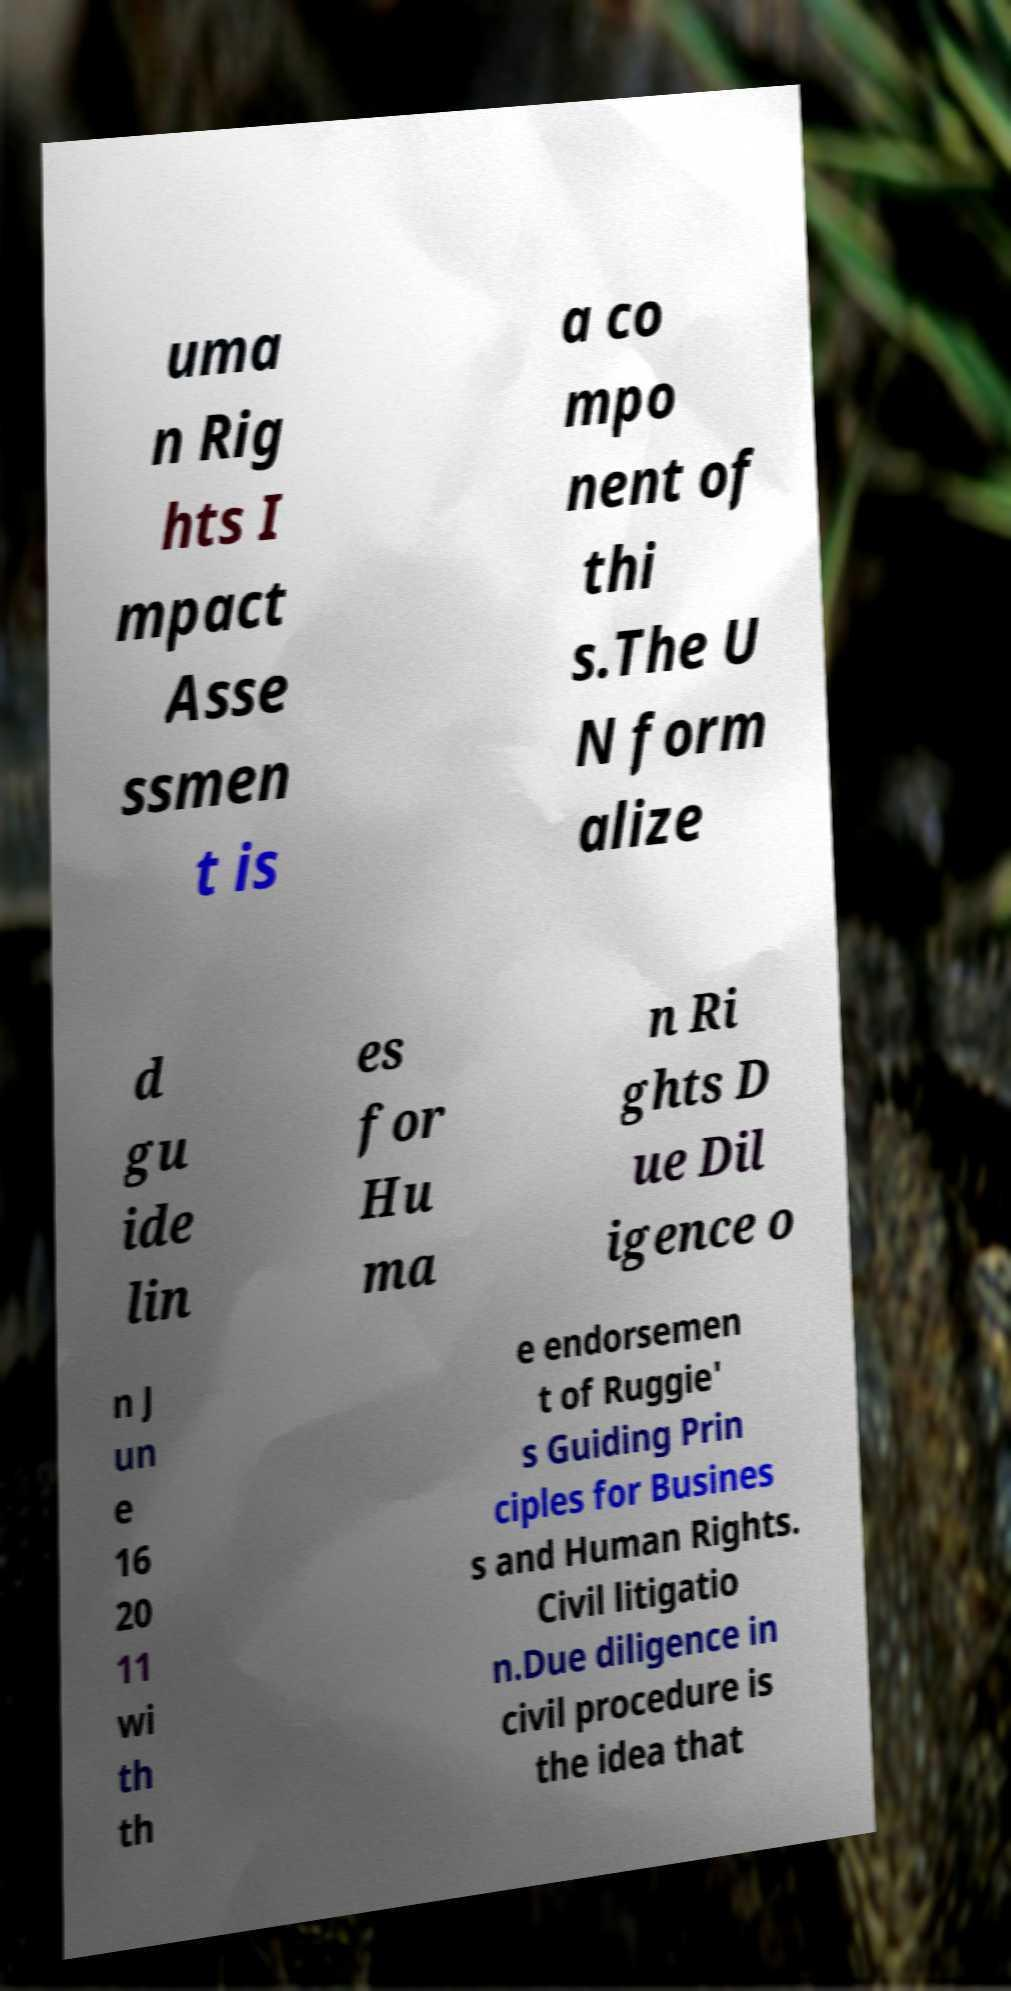Can you accurately transcribe the text from the provided image for me? uma n Rig hts I mpact Asse ssmen t is a co mpo nent of thi s.The U N form alize d gu ide lin es for Hu ma n Ri ghts D ue Dil igence o n J un e 16 20 11 wi th th e endorsemen t of Ruggie' s Guiding Prin ciples for Busines s and Human Rights. Civil litigatio n.Due diligence in civil procedure is the idea that 